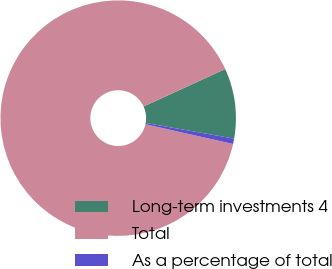Convert chart. <chart><loc_0><loc_0><loc_500><loc_500><pie_chart><fcel>Long-term investments 4<fcel>Total<fcel>As a percentage of total<nl><fcel>9.63%<fcel>89.64%<fcel>0.74%<nl></chart> 